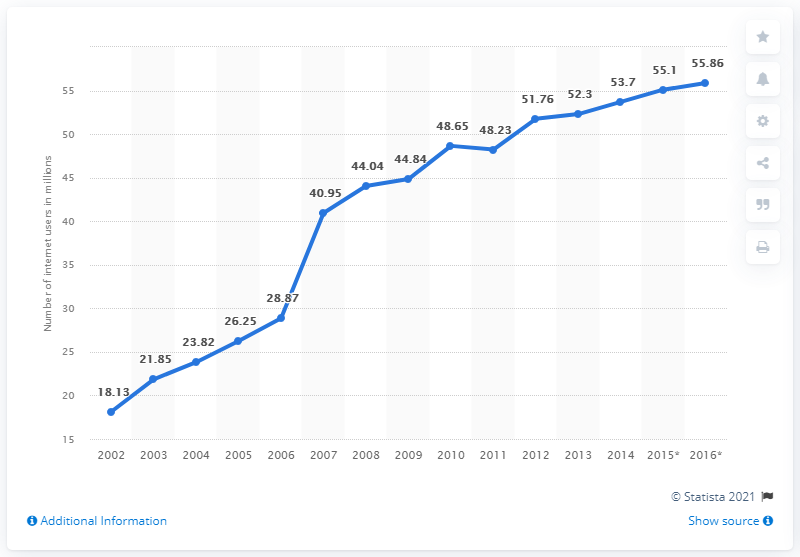Give some essential details in this illustration. In the previous year, 53.7% of people in France had access to the internet. In 2015, it was estimated that 55.1% of the population in France had access to the internet. 